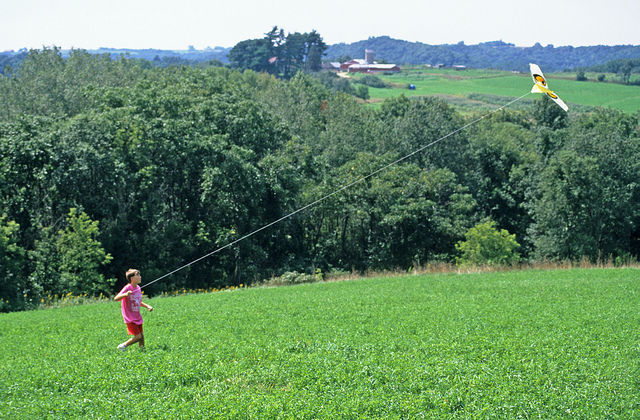Imagine a friendly dragon suddenly joins the kid to help fly the kite. Describe the scene. In a burst of magic, a friendly dragon swoops down from the sky, its scales shimmering in the sunlight. The child looks up in awe as the dragon gently lands beside them, its warm, gentle eyes inviting trust. Together, they take to the sky, with the dragon lifting the kite even higher with each flap of its wings. The dragon's presence transforms the meadow into a fantastical playground, where the child’s laughter echoes through the trees, and the kite dances with vibrant colors against the backdrop of the bright blue sky. The serene countryside becomes a realm of endless possibilities and adventures. 